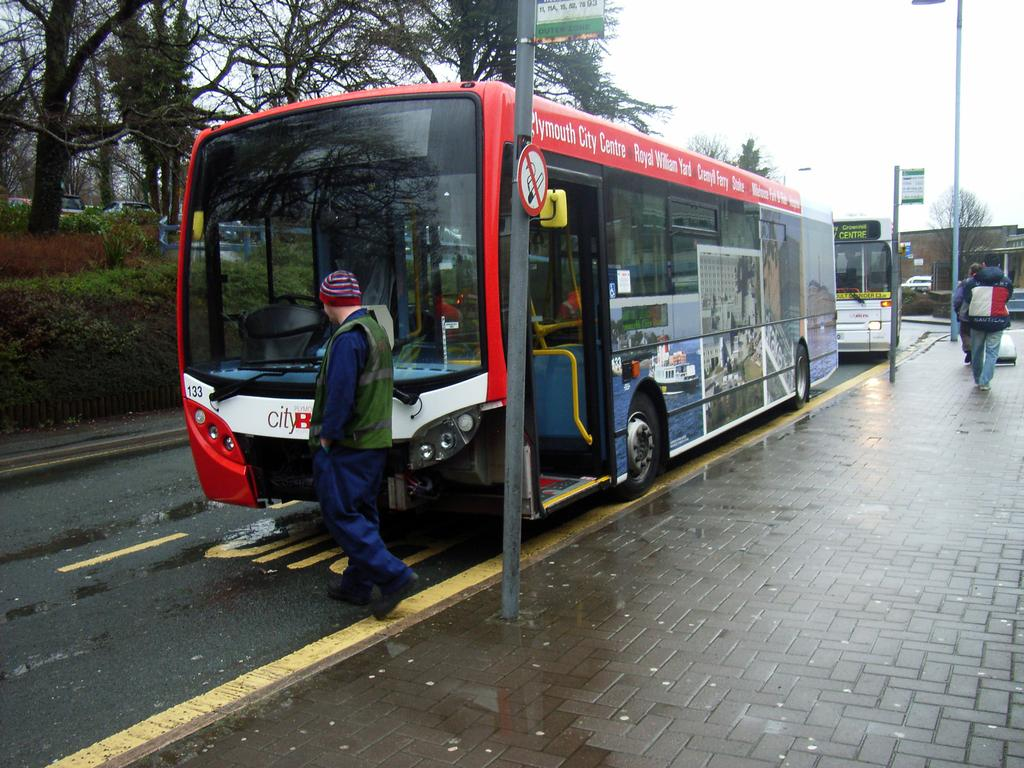What types of vehicles can be seen on the road in the image? There are motor vehicles on the road in the image. Are there any people present on the road? Yes, there are persons on the road in the image. What structures can be seen in the image? There are poles, sign boards, and a fence in the image. What type of vegetation is present in the image? There are plants and trees in the image. What is the color of the silk in the image? There is no silk present in the image. Can you describe the texture of the stone in the image? There is no stone present in the image. How many yaks can be seen in the image? There are no yaks present in the image. 